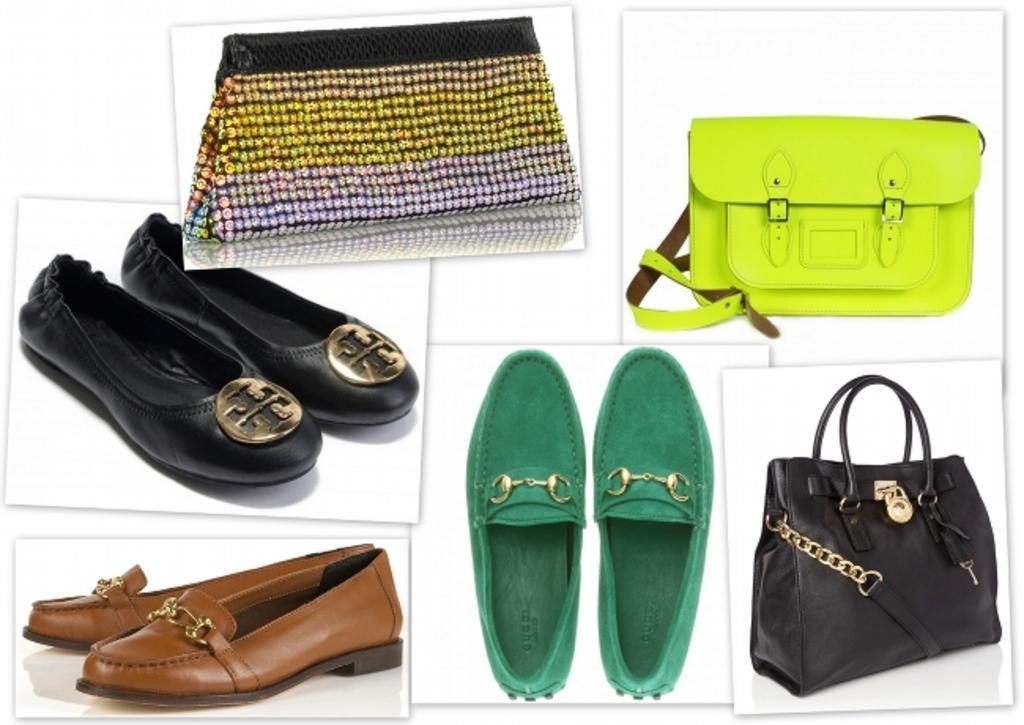How would you summarize this image in a sentence or two? In this picture we can see some foot wears and bags where we can see black, green and multicolor bags. 